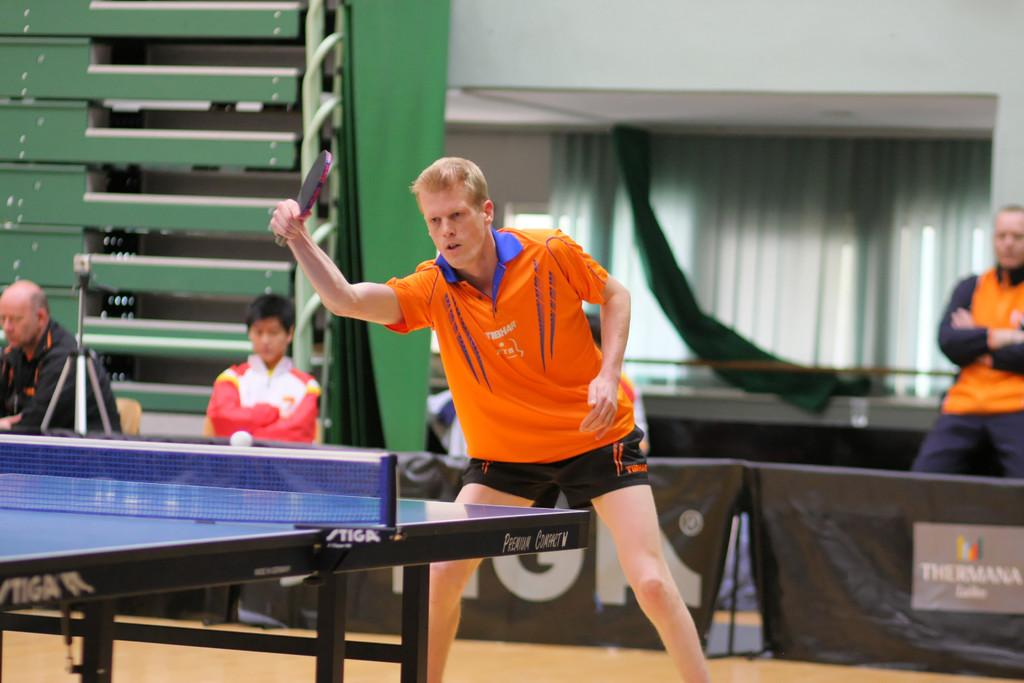What is the person holding in the image? The person is holding a bat. What activity is the person with the bat engaged in? The person is playing table tennis. How many people are sitting in the image? There are two persons sitting on chairs. What is the background of the person playing table tennis? There is a wall visible behind the person playing table tennis, and a curtain is associated with the wall. Can you describe the person visible behind the wall? There is a person visible behind the wall, but no specific details about this person are provided in the facts. What decorative elements are present in the image? There are banners visible in the image. What type of act is the person performing in the image? The person is not performing an act in the image; they are playing table tennis. Is there a rainstorm occurring in the image? There is no mention of a rainstorm in the image; the facts only mention the presence of a wall, curtain, and banners. 